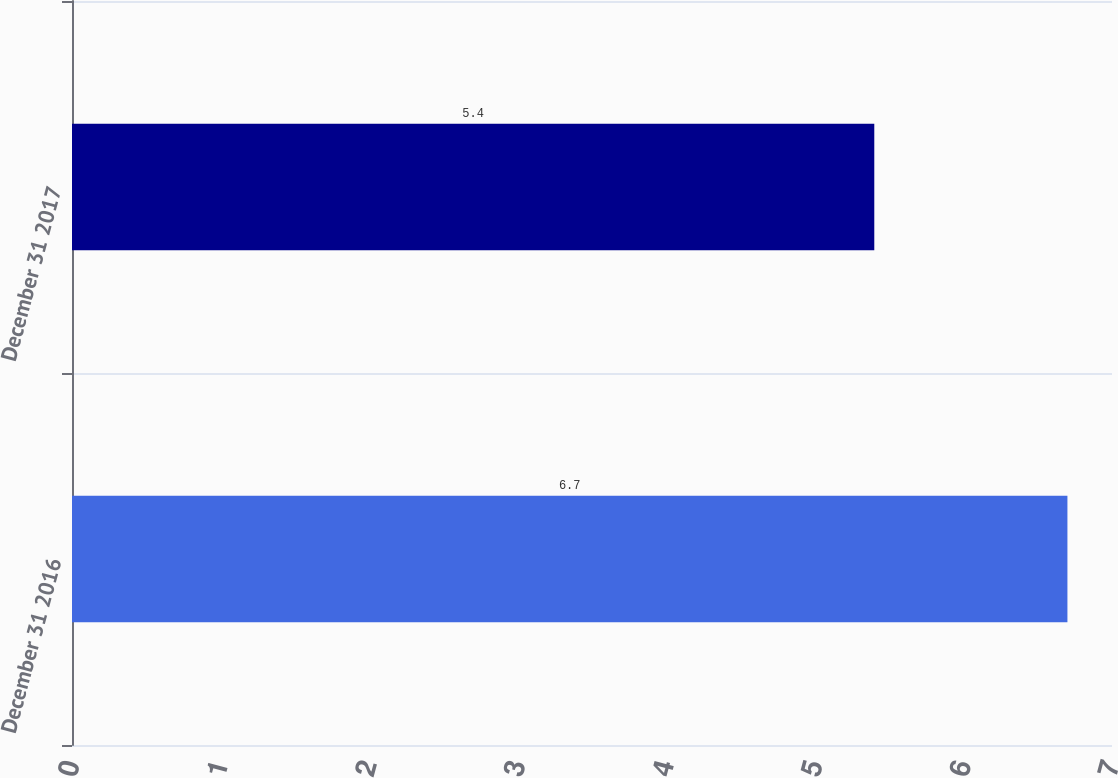Convert chart to OTSL. <chart><loc_0><loc_0><loc_500><loc_500><bar_chart><fcel>December 31 2016<fcel>December 31 2017<nl><fcel>6.7<fcel>5.4<nl></chart> 